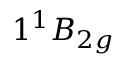<formula> <loc_0><loc_0><loc_500><loc_500>1 ^ { 1 } B _ { 2 g }</formula> 